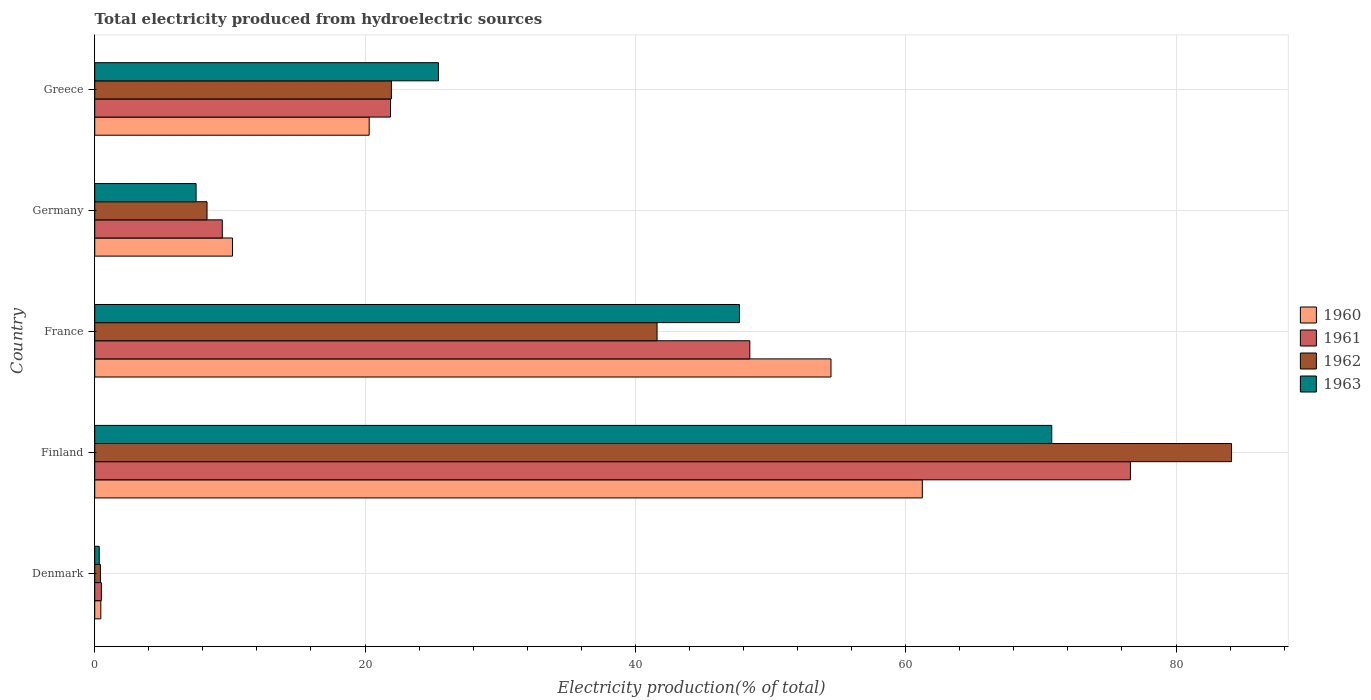How many different coloured bars are there?
Make the answer very short. 4. Are the number of bars per tick equal to the number of legend labels?
Your response must be concise. Yes. Are the number of bars on each tick of the Y-axis equal?
Give a very brief answer. Yes. How many bars are there on the 3rd tick from the top?
Your answer should be very brief. 4. What is the label of the 2nd group of bars from the top?
Your response must be concise. Germany. In how many cases, is the number of bars for a given country not equal to the number of legend labels?
Provide a short and direct response. 0. What is the total electricity produced in 1960 in France?
Keep it short and to the point. 54.47. Across all countries, what is the maximum total electricity produced in 1963?
Your response must be concise. 70.81. Across all countries, what is the minimum total electricity produced in 1962?
Ensure brevity in your answer.  0.42. What is the total total electricity produced in 1963 in the graph?
Make the answer very short. 151.77. What is the difference between the total electricity produced in 1962 in Denmark and that in Finland?
Offer a terse response. -83.69. What is the difference between the total electricity produced in 1963 in France and the total electricity produced in 1960 in Germany?
Your answer should be very brief. 37.51. What is the average total electricity produced in 1963 per country?
Keep it short and to the point. 30.35. What is the difference between the total electricity produced in 1962 and total electricity produced in 1960 in Finland?
Give a very brief answer. 22.88. What is the ratio of the total electricity produced in 1961 in Denmark to that in Greece?
Your answer should be very brief. 0.02. Is the total electricity produced in 1960 in France less than that in Greece?
Make the answer very short. No. What is the difference between the highest and the second highest total electricity produced in 1961?
Make the answer very short. 28.16. What is the difference between the highest and the lowest total electricity produced in 1960?
Offer a very short reply. 60.78. Is the sum of the total electricity produced in 1962 in Finland and France greater than the maximum total electricity produced in 1963 across all countries?
Keep it short and to the point. Yes. What does the 2nd bar from the top in Germany represents?
Provide a short and direct response. 1962. Does the graph contain any zero values?
Keep it short and to the point. No. Where does the legend appear in the graph?
Offer a very short reply. Center right. What is the title of the graph?
Provide a short and direct response. Total electricity produced from hydroelectric sources. What is the Electricity production(% of total) in 1960 in Denmark?
Keep it short and to the point. 0.45. What is the Electricity production(% of total) in 1961 in Denmark?
Your response must be concise. 0.49. What is the Electricity production(% of total) of 1962 in Denmark?
Your response must be concise. 0.42. What is the Electricity production(% of total) of 1963 in Denmark?
Your response must be concise. 0.33. What is the Electricity production(% of total) of 1960 in Finland?
Your answer should be compact. 61.23. What is the Electricity production(% of total) of 1961 in Finland?
Ensure brevity in your answer.  76.63. What is the Electricity production(% of total) in 1962 in Finland?
Your response must be concise. 84.11. What is the Electricity production(% of total) in 1963 in Finland?
Offer a terse response. 70.81. What is the Electricity production(% of total) in 1960 in France?
Your answer should be compact. 54.47. What is the Electricity production(% of total) of 1961 in France?
Provide a succinct answer. 48.47. What is the Electricity production(% of total) of 1962 in France?
Give a very brief answer. 41.61. What is the Electricity production(% of total) in 1963 in France?
Offer a very short reply. 47.7. What is the Electricity production(% of total) in 1960 in Germany?
Provide a succinct answer. 10.19. What is the Electricity production(% of total) in 1961 in Germany?
Make the answer very short. 9.44. What is the Electricity production(% of total) in 1962 in Germany?
Offer a terse response. 8.31. What is the Electricity production(% of total) of 1963 in Germany?
Offer a terse response. 7.5. What is the Electricity production(% of total) in 1960 in Greece?
Your answer should be compact. 20.31. What is the Electricity production(% of total) of 1961 in Greece?
Your answer should be very brief. 21.88. What is the Electricity production(% of total) in 1962 in Greece?
Provide a succinct answer. 21.95. What is the Electricity production(% of total) of 1963 in Greece?
Your answer should be very brief. 25.43. Across all countries, what is the maximum Electricity production(% of total) of 1960?
Make the answer very short. 61.23. Across all countries, what is the maximum Electricity production(% of total) in 1961?
Provide a short and direct response. 76.63. Across all countries, what is the maximum Electricity production(% of total) in 1962?
Offer a terse response. 84.11. Across all countries, what is the maximum Electricity production(% of total) of 1963?
Provide a succinct answer. 70.81. Across all countries, what is the minimum Electricity production(% of total) in 1960?
Make the answer very short. 0.45. Across all countries, what is the minimum Electricity production(% of total) of 1961?
Give a very brief answer. 0.49. Across all countries, what is the minimum Electricity production(% of total) of 1962?
Give a very brief answer. 0.42. Across all countries, what is the minimum Electricity production(% of total) in 1963?
Offer a terse response. 0.33. What is the total Electricity production(% of total) in 1960 in the graph?
Offer a very short reply. 146.65. What is the total Electricity production(% of total) of 1961 in the graph?
Give a very brief answer. 156.91. What is the total Electricity production(% of total) of 1962 in the graph?
Make the answer very short. 156.39. What is the total Electricity production(% of total) of 1963 in the graph?
Ensure brevity in your answer.  151.77. What is the difference between the Electricity production(% of total) of 1960 in Denmark and that in Finland?
Offer a terse response. -60.78. What is the difference between the Electricity production(% of total) in 1961 in Denmark and that in Finland?
Your answer should be compact. -76.14. What is the difference between the Electricity production(% of total) of 1962 in Denmark and that in Finland?
Offer a terse response. -83.69. What is the difference between the Electricity production(% of total) in 1963 in Denmark and that in Finland?
Your answer should be compact. -70.47. What is the difference between the Electricity production(% of total) in 1960 in Denmark and that in France?
Ensure brevity in your answer.  -54.02. What is the difference between the Electricity production(% of total) of 1961 in Denmark and that in France?
Your answer should be compact. -47.98. What is the difference between the Electricity production(% of total) of 1962 in Denmark and that in France?
Offer a very short reply. -41.18. What is the difference between the Electricity production(% of total) of 1963 in Denmark and that in France?
Offer a terse response. -47.37. What is the difference between the Electricity production(% of total) of 1960 in Denmark and that in Germany?
Make the answer very short. -9.74. What is the difference between the Electricity production(% of total) in 1961 in Denmark and that in Germany?
Ensure brevity in your answer.  -8.95. What is the difference between the Electricity production(% of total) in 1962 in Denmark and that in Germany?
Your answer should be very brief. -7.89. What is the difference between the Electricity production(% of total) of 1963 in Denmark and that in Germany?
Your answer should be very brief. -7.17. What is the difference between the Electricity production(% of total) in 1960 in Denmark and that in Greece?
Your response must be concise. -19.85. What is the difference between the Electricity production(% of total) of 1961 in Denmark and that in Greece?
Keep it short and to the point. -21.39. What is the difference between the Electricity production(% of total) in 1962 in Denmark and that in Greece?
Give a very brief answer. -21.53. What is the difference between the Electricity production(% of total) of 1963 in Denmark and that in Greece?
Your answer should be compact. -25.09. What is the difference between the Electricity production(% of total) of 1960 in Finland and that in France?
Ensure brevity in your answer.  6.76. What is the difference between the Electricity production(% of total) of 1961 in Finland and that in France?
Provide a succinct answer. 28.16. What is the difference between the Electricity production(% of total) in 1962 in Finland and that in France?
Your response must be concise. 42.5. What is the difference between the Electricity production(% of total) of 1963 in Finland and that in France?
Make the answer very short. 23.11. What is the difference between the Electricity production(% of total) of 1960 in Finland and that in Germany?
Your answer should be very brief. 51.04. What is the difference between the Electricity production(% of total) in 1961 in Finland and that in Germany?
Offer a terse response. 67.19. What is the difference between the Electricity production(% of total) in 1962 in Finland and that in Germany?
Your response must be concise. 75.8. What is the difference between the Electricity production(% of total) in 1963 in Finland and that in Germany?
Provide a succinct answer. 63.31. What is the difference between the Electricity production(% of total) of 1960 in Finland and that in Greece?
Provide a short and direct response. 40.93. What is the difference between the Electricity production(% of total) in 1961 in Finland and that in Greece?
Provide a succinct answer. 54.75. What is the difference between the Electricity production(% of total) in 1962 in Finland and that in Greece?
Your response must be concise. 62.16. What is the difference between the Electricity production(% of total) of 1963 in Finland and that in Greece?
Give a very brief answer. 45.38. What is the difference between the Electricity production(% of total) of 1960 in France and that in Germany?
Make the answer very short. 44.28. What is the difference between the Electricity production(% of total) of 1961 in France and that in Germany?
Your response must be concise. 39.03. What is the difference between the Electricity production(% of total) of 1962 in France and that in Germany?
Make the answer very short. 33.3. What is the difference between the Electricity production(% of total) in 1963 in France and that in Germany?
Your answer should be very brief. 40.2. What is the difference between the Electricity production(% of total) in 1960 in France and that in Greece?
Give a very brief answer. 34.17. What is the difference between the Electricity production(% of total) in 1961 in France and that in Greece?
Keep it short and to the point. 26.58. What is the difference between the Electricity production(% of total) in 1962 in France and that in Greece?
Keep it short and to the point. 19.66. What is the difference between the Electricity production(% of total) of 1963 in France and that in Greece?
Offer a very short reply. 22.27. What is the difference between the Electricity production(% of total) in 1960 in Germany and that in Greece?
Give a very brief answer. -10.11. What is the difference between the Electricity production(% of total) in 1961 in Germany and that in Greece?
Keep it short and to the point. -12.45. What is the difference between the Electricity production(% of total) of 1962 in Germany and that in Greece?
Make the answer very short. -13.64. What is the difference between the Electricity production(% of total) of 1963 in Germany and that in Greece?
Offer a very short reply. -17.93. What is the difference between the Electricity production(% of total) of 1960 in Denmark and the Electricity production(% of total) of 1961 in Finland?
Your response must be concise. -76.18. What is the difference between the Electricity production(% of total) of 1960 in Denmark and the Electricity production(% of total) of 1962 in Finland?
Provide a succinct answer. -83.66. What is the difference between the Electricity production(% of total) of 1960 in Denmark and the Electricity production(% of total) of 1963 in Finland?
Ensure brevity in your answer.  -70.36. What is the difference between the Electricity production(% of total) in 1961 in Denmark and the Electricity production(% of total) in 1962 in Finland?
Your response must be concise. -83.62. What is the difference between the Electricity production(% of total) of 1961 in Denmark and the Electricity production(% of total) of 1963 in Finland?
Your answer should be very brief. -70.32. What is the difference between the Electricity production(% of total) of 1962 in Denmark and the Electricity production(% of total) of 1963 in Finland?
Give a very brief answer. -70.39. What is the difference between the Electricity production(% of total) of 1960 in Denmark and the Electricity production(% of total) of 1961 in France?
Your response must be concise. -48.02. What is the difference between the Electricity production(% of total) in 1960 in Denmark and the Electricity production(% of total) in 1962 in France?
Provide a succinct answer. -41.15. What is the difference between the Electricity production(% of total) of 1960 in Denmark and the Electricity production(% of total) of 1963 in France?
Your response must be concise. -47.25. What is the difference between the Electricity production(% of total) in 1961 in Denmark and the Electricity production(% of total) in 1962 in France?
Make the answer very short. -41.12. What is the difference between the Electricity production(% of total) in 1961 in Denmark and the Electricity production(% of total) in 1963 in France?
Offer a terse response. -47.21. What is the difference between the Electricity production(% of total) of 1962 in Denmark and the Electricity production(% of total) of 1963 in France?
Make the answer very short. -47.28. What is the difference between the Electricity production(% of total) in 1960 in Denmark and the Electricity production(% of total) in 1961 in Germany?
Ensure brevity in your answer.  -8.99. What is the difference between the Electricity production(% of total) of 1960 in Denmark and the Electricity production(% of total) of 1962 in Germany?
Make the answer very short. -7.86. What is the difference between the Electricity production(% of total) of 1960 in Denmark and the Electricity production(% of total) of 1963 in Germany?
Provide a short and direct response. -7.05. What is the difference between the Electricity production(% of total) of 1961 in Denmark and the Electricity production(% of total) of 1962 in Germany?
Offer a terse response. -7.82. What is the difference between the Electricity production(% of total) in 1961 in Denmark and the Electricity production(% of total) in 1963 in Germany?
Your answer should be compact. -7.01. What is the difference between the Electricity production(% of total) of 1962 in Denmark and the Electricity production(% of total) of 1963 in Germany?
Make the answer very short. -7.08. What is the difference between the Electricity production(% of total) in 1960 in Denmark and the Electricity production(% of total) in 1961 in Greece?
Provide a short and direct response. -21.43. What is the difference between the Electricity production(% of total) of 1960 in Denmark and the Electricity production(% of total) of 1962 in Greece?
Give a very brief answer. -21.5. What is the difference between the Electricity production(% of total) of 1960 in Denmark and the Electricity production(% of total) of 1963 in Greece?
Make the answer very short. -24.98. What is the difference between the Electricity production(% of total) of 1961 in Denmark and the Electricity production(% of total) of 1962 in Greece?
Provide a succinct answer. -21.46. What is the difference between the Electricity production(% of total) of 1961 in Denmark and the Electricity production(% of total) of 1963 in Greece?
Offer a very short reply. -24.94. What is the difference between the Electricity production(% of total) of 1962 in Denmark and the Electricity production(% of total) of 1963 in Greece?
Provide a succinct answer. -25.01. What is the difference between the Electricity production(% of total) of 1960 in Finland and the Electricity production(% of total) of 1961 in France?
Give a very brief answer. 12.76. What is the difference between the Electricity production(% of total) in 1960 in Finland and the Electricity production(% of total) in 1962 in France?
Make the answer very short. 19.63. What is the difference between the Electricity production(% of total) in 1960 in Finland and the Electricity production(% of total) in 1963 in France?
Provide a succinct answer. 13.53. What is the difference between the Electricity production(% of total) of 1961 in Finland and the Electricity production(% of total) of 1962 in France?
Provide a succinct answer. 35.02. What is the difference between the Electricity production(% of total) of 1961 in Finland and the Electricity production(% of total) of 1963 in France?
Give a very brief answer. 28.93. What is the difference between the Electricity production(% of total) in 1962 in Finland and the Electricity production(% of total) in 1963 in France?
Ensure brevity in your answer.  36.41. What is the difference between the Electricity production(% of total) of 1960 in Finland and the Electricity production(% of total) of 1961 in Germany?
Offer a terse response. 51.8. What is the difference between the Electricity production(% of total) in 1960 in Finland and the Electricity production(% of total) in 1962 in Germany?
Your answer should be compact. 52.92. What is the difference between the Electricity production(% of total) in 1960 in Finland and the Electricity production(% of total) in 1963 in Germany?
Your response must be concise. 53.73. What is the difference between the Electricity production(% of total) in 1961 in Finland and the Electricity production(% of total) in 1962 in Germany?
Make the answer very short. 68.32. What is the difference between the Electricity production(% of total) in 1961 in Finland and the Electricity production(% of total) in 1963 in Germany?
Provide a short and direct response. 69.13. What is the difference between the Electricity production(% of total) in 1962 in Finland and the Electricity production(% of total) in 1963 in Germany?
Provide a short and direct response. 76.61. What is the difference between the Electricity production(% of total) of 1960 in Finland and the Electricity production(% of total) of 1961 in Greece?
Give a very brief answer. 39.35. What is the difference between the Electricity production(% of total) in 1960 in Finland and the Electricity production(% of total) in 1962 in Greece?
Keep it short and to the point. 39.28. What is the difference between the Electricity production(% of total) in 1960 in Finland and the Electricity production(% of total) in 1963 in Greece?
Provide a succinct answer. 35.8. What is the difference between the Electricity production(% of total) of 1961 in Finland and the Electricity production(% of total) of 1962 in Greece?
Give a very brief answer. 54.68. What is the difference between the Electricity production(% of total) of 1961 in Finland and the Electricity production(% of total) of 1963 in Greece?
Your response must be concise. 51.2. What is the difference between the Electricity production(% of total) in 1962 in Finland and the Electricity production(% of total) in 1963 in Greece?
Ensure brevity in your answer.  58.68. What is the difference between the Electricity production(% of total) in 1960 in France and the Electricity production(% of total) in 1961 in Germany?
Keep it short and to the point. 45.04. What is the difference between the Electricity production(% of total) of 1960 in France and the Electricity production(% of total) of 1962 in Germany?
Keep it short and to the point. 46.16. What is the difference between the Electricity production(% of total) in 1960 in France and the Electricity production(% of total) in 1963 in Germany?
Your answer should be compact. 46.97. What is the difference between the Electricity production(% of total) of 1961 in France and the Electricity production(% of total) of 1962 in Germany?
Offer a very short reply. 40.16. What is the difference between the Electricity production(% of total) in 1961 in France and the Electricity production(% of total) in 1963 in Germany?
Provide a short and direct response. 40.97. What is the difference between the Electricity production(% of total) of 1962 in France and the Electricity production(% of total) of 1963 in Germany?
Give a very brief answer. 34.11. What is the difference between the Electricity production(% of total) in 1960 in France and the Electricity production(% of total) in 1961 in Greece?
Ensure brevity in your answer.  32.59. What is the difference between the Electricity production(% of total) in 1960 in France and the Electricity production(% of total) in 1962 in Greece?
Your response must be concise. 32.52. What is the difference between the Electricity production(% of total) of 1960 in France and the Electricity production(% of total) of 1963 in Greece?
Offer a terse response. 29.05. What is the difference between the Electricity production(% of total) in 1961 in France and the Electricity production(% of total) in 1962 in Greece?
Ensure brevity in your answer.  26.52. What is the difference between the Electricity production(% of total) in 1961 in France and the Electricity production(% of total) in 1963 in Greece?
Your response must be concise. 23.04. What is the difference between the Electricity production(% of total) of 1962 in France and the Electricity production(% of total) of 1963 in Greece?
Offer a terse response. 16.18. What is the difference between the Electricity production(% of total) of 1960 in Germany and the Electricity production(% of total) of 1961 in Greece?
Offer a very short reply. -11.69. What is the difference between the Electricity production(% of total) of 1960 in Germany and the Electricity production(% of total) of 1962 in Greece?
Ensure brevity in your answer.  -11.76. What is the difference between the Electricity production(% of total) of 1960 in Germany and the Electricity production(% of total) of 1963 in Greece?
Offer a very short reply. -15.24. What is the difference between the Electricity production(% of total) of 1961 in Germany and the Electricity production(% of total) of 1962 in Greece?
Your answer should be very brief. -12.51. What is the difference between the Electricity production(% of total) in 1961 in Germany and the Electricity production(% of total) in 1963 in Greece?
Your response must be concise. -15.99. What is the difference between the Electricity production(% of total) of 1962 in Germany and the Electricity production(% of total) of 1963 in Greece?
Ensure brevity in your answer.  -17.12. What is the average Electricity production(% of total) of 1960 per country?
Offer a terse response. 29.33. What is the average Electricity production(% of total) of 1961 per country?
Provide a short and direct response. 31.38. What is the average Electricity production(% of total) of 1962 per country?
Keep it short and to the point. 31.28. What is the average Electricity production(% of total) of 1963 per country?
Make the answer very short. 30.35. What is the difference between the Electricity production(% of total) in 1960 and Electricity production(% of total) in 1961 in Denmark?
Provide a succinct answer. -0.04. What is the difference between the Electricity production(% of total) of 1960 and Electricity production(% of total) of 1962 in Denmark?
Offer a very short reply. 0.03. What is the difference between the Electricity production(% of total) of 1960 and Electricity production(% of total) of 1963 in Denmark?
Your response must be concise. 0.12. What is the difference between the Electricity production(% of total) of 1961 and Electricity production(% of total) of 1962 in Denmark?
Provide a short and direct response. 0.07. What is the difference between the Electricity production(% of total) of 1961 and Electricity production(% of total) of 1963 in Denmark?
Your answer should be very brief. 0.15. What is the difference between the Electricity production(% of total) of 1962 and Electricity production(% of total) of 1963 in Denmark?
Provide a succinct answer. 0.09. What is the difference between the Electricity production(% of total) in 1960 and Electricity production(% of total) in 1961 in Finland?
Your answer should be compact. -15.4. What is the difference between the Electricity production(% of total) in 1960 and Electricity production(% of total) in 1962 in Finland?
Provide a short and direct response. -22.88. What is the difference between the Electricity production(% of total) of 1960 and Electricity production(% of total) of 1963 in Finland?
Your answer should be very brief. -9.58. What is the difference between the Electricity production(% of total) in 1961 and Electricity production(% of total) in 1962 in Finland?
Provide a short and direct response. -7.48. What is the difference between the Electricity production(% of total) of 1961 and Electricity production(% of total) of 1963 in Finland?
Your answer should be very brief. 5.82. What is the difference between the Electricity production(% of total) of 1962 and Electricity production(% of total) of 1963 in Finland?
Make the answer very short. 13.3. What is the difference between the Electricity production(% of total) of 1960 and Electricity production(% of total) of 1961 in France?
Ensure brevity in your answer.  6.01. What is the difference between the Electricity production(% of total) in 1960 and Electricity production(% of total) in 1962 in France?
Ensure brevity in your answer.  12.87. What is the difference between the Electricity production(% of total) of 1960 and Electricity production(% of total) of 1963 in France?
Offer a terse response. 6.77. What is the difference between the Electricity production(% of total) in 1961 and Electricity production(% of total) in 1962 in France?
Ensure brevity in your answer.  6.86. What is the difference between the Electricity production(% of total) of 1961 and Electricity production(% of total) of 1963 in France?
Provide a succinct answer. 0.77. What is the difference between the Electricity production(% of total) in 1962 and Electricity production(% of total) in 1963 in France?
Offer a very short reply. -6.1. What is the difference between the Electricity production(% of total) in 1960 and Electricity production(% of total) in 1961 in Germany?
Your answer should be compact. 0.76. What is the difference between the Electricity production(% of total) in 1960 and Electricity production(% of total) in 1962 in Germany?
Keep it short and to the point. 1.88. What is the difference between the Electricity production(% of total) of 1960 and Electricity production(% of total) of 1963 in Germany?
Make the answer very short. 2.69. What is the difference between the Electricity production(% of total) in 1961 and Electricity production(% of total) in 1962 in Germany?
Give a very brief answer. 1.13. What is the difference between the Electricity production(% of total) in 1961 and Electricity production(% of total) in 1963 in Germany?
Your response must be concise. 1.94. What is the difference between the Electricity production(% of total) in 1962 and Electricity production(% of total) in 1963 in Germany?
Offer a very short reply. 0.81. What is the difference between the Electricity production(% of total) in 1960 and Electricity production(% of total) in 1961 in Greece?
Ensure brevity in your answer.  -1.58. What is the difference between the Electricity production(% of total) in 1960 and Electricity production(% of total) in 1962 in Greece?
Provide a succinct answer. -1.64. What is the difference between the Electricity production(% of total) of 1960 and Electricity production(% of total) of 1963 in Greece?
Offer a terse response. -5.12. What is the difference between the Electricity production(% of total) in 1961 and Electricity production(% of total) in 1962 in Greece?
Provide a succinct answer. -0.07. What is the difference between the Electricity production(% of total) of 1961 and Electricity production(% of total) of 1963 in Greece?
Your answer should be compact. -3.54. What is the difference between the Electricity production(% of total) in 1962 and Electricity production(% of total) in 1963 in Greece?
Provide a succinct answer. -3.48. What is the ratio of the Electricity production(% of total) in 1960 in Denmark to that in Finland?
Provide a short and direct response. 0.01. What is the ratio of the Electricity production(% of total) of 1961 in Denmark to that in Finland?
Keep it short and to the point. 0.01. What is the ratio of the Electricity production(% of total) of 1962 in Denmark to that in Finland?
Keep it short and to the point. 0.01. What is the ratio of the Electricity production(% of total) in 1963 in Denmark to that in Finland?
Your answer should be compact. 0. What is the ratio of the Electricity production(% of total) of 1960 in Denmark to that in France?
Provide a succinct answer. 0.01. What is the ratio of the Electricity production(% of total) of 1961 in Denmark to that in France?
Offer a very short reply. 0.01. What is the ratio of the Electricity production(% of total) in 1962 in Denmark to that in France?
Your response must be concise. 0.01. What is the ratio of the Electricity production(% of total) of 1963 in Denmark to that in France?
Ensure brevity in your answer.  0.01. What is the ratio of the Electricity production(% of total) in 1960 in Denmark to that in Germany?
Your answer should be compact. 0.04. What is the ratio of the Electricity production(% of total) in 1961 in Denmark to that in Germany?
Ensure brevity in your answer.  0.05. What is the ratio of the Electricity production(% of total) in 1962 in Denmark to that in Germany?
Offer a very short reply. 0.05. What is the ratio of the Electricity production(% of total) of 1963 in Denmark to that in Germany?
Make the answer very short. 0.04. What is the ratio of the Electricity production(% of total) in 1960 in Denmark to that in Greece?
Ensure brevity in your answer.  0.02. What is the ratio of the Electricity production(% of total) in 1961 in Denmark to that in Greece?
Your answer should be very brief. 0.02. What is the ratio of the Electricity production(% of total) of 1962 in Denmark to that in Greece?
Your response must be concise. 0.02. What is the ratio of the Electricity production(% of total) of 1963 in Denmark to that in Greece?
Offer a very short reply. 0.01. What is the ratio of the Electricity production(% of total) in 1960 in Finland to that in France?
Offer a terse response. 1.12. What is the ratio of the Electricity production(% of total) in 1961 in Finland to that in France?
Ensure brevity in your answer.  1.58. What is the ratio of the Electricity production(% of total) in 1962 in Finland to that in France?
Offer a terse response. 2.02. What is the ratio of the Electricity production(% of total) in 1963 in Finland to that in France?
Provide a succinct answer. 1.48. What is the ratio of the Electricity production(% of total) in 1960 in Finland to that in Germany?
Provide a short and direct response. 6.01. What is the ratio of the Electricity production(% of total) of 1961 in Finland to that in Germany?
Make the answer very short. 8.12. What is the ratio of the Electricity production(% of total) of 1962 in Finland to that in Germany?
Give a very brief answer. 10.12. What is the ratio of the Electricity production(% of total) of 1963 in Finland to that in Germany?
Offer a very short reply. 9.44. What is the ratio of the Electricity production(% of total) in 1960 in Finland to that in Greece?
Your response must be concise. 3.02. What is the ratio of the Electricity production(% of total) of 1961 in Finland to that in Greece?
Provide a succinct answer. 3.5. What is the ratio of the Electricity production(% of total) in 1962 in Finland to that in Greece?
Give a very brief answer. 3.83. What is the ratio of the Electricity production(% of total) of 1963 in Finland to that in Greece?
Keep it short and to the point. 2.78. What is the ratio of the Electricity production(% of total) of 1960 in France to that in Germany?
Give a very brief answer. 5.34. What is the ratio of the Electricity production(% of total) of 1961 in France to that in Germany?
Ensure brevity in your answer.  5.14. What is the ratio of the Electricity production(% of total) in 1962 in France to that in Germany?
Provide a succinct answer. 5.01. What is the ratio of the Electricity production(% of total) of 1963 in France to that in Germany?
Provide a short and direct response. 6.36. What is the ratio of the Electricity production(% of total) of 1960 in France to that in Greece?
Make the answer very short. 2.68. What is the ratio of the Electricity production(% of total) of 1961 in France to that in Greece?
Make the answer very short. 2.21. What is the ratio of the Electricity production(% of total) of 1962 in France to that in Greece?
Provide a short and direct response. 1.9. What is the ratio of the Electricity production(% of total) of 1963 in France to that in Greece?
Provide a succinct answer. 1.88. What is the ratio of the Electricity production(% of total) in 1960 in Germany to that in Greece?
Make the answer very short. 0.5. What is the ratio of the Electricity production(% of total) of 1961 in Germany to that in Greece?
Your answer should be compact. 0.43. What is the ratio of the Electricity production(% of total) of 1962 in Germany to that in Greece?
Keep it short and to the point. 0.38. What is the ratio of the Electricity production(% of total) in 1963 in Germany to that in Greece?
Provide a short and direct response. 0.29. What is the difference between the highest and the second highest Electricity production(% of total) of 1960?
Make the answer very short. 6.76. What is the difference between the highest and the second highest Electricity production(% of total) in 1961?
Offer a terse response. 28.16. What is the difference between the highest and the second highest Electricity production(% of total) in 1962?
Your response must be concise. 42.5. What is the difference between the highest and the second highest Electricity production(% of total) in 1963?
Keep it short and to the point. 23.11. What is the difference between the highest and the lowest Electricity production(% of total) of 1960?
Provide a succinct answer. 60.78. What is the difference between the highest and the lowest Electricity production(% of total) of 1961?
Make the answer very short. 76.14. What is the difference between the highest and the lowest Electricity production(% of total) in 1962?
Your response must be concise. 83.69. What is the difference between the highest and the lowest Electricity production(% of total) in 1963?
Offer a terse response. 70.47. 